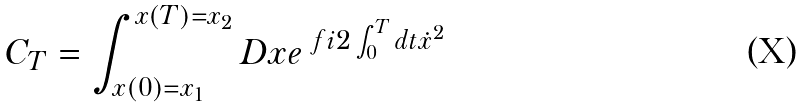<formula> <loc_0><loc_0><loc_500><loc_500>C _ { T } = \int ^ { x ( T ) = x _ { 2 } } _ { x ( 0 ) = x _ { 1 } } D x e ^ { \ f { i } { 2 } \int ^ { T } _ { 0 } d t \dot { x } ^ { 2 } }</formula> 